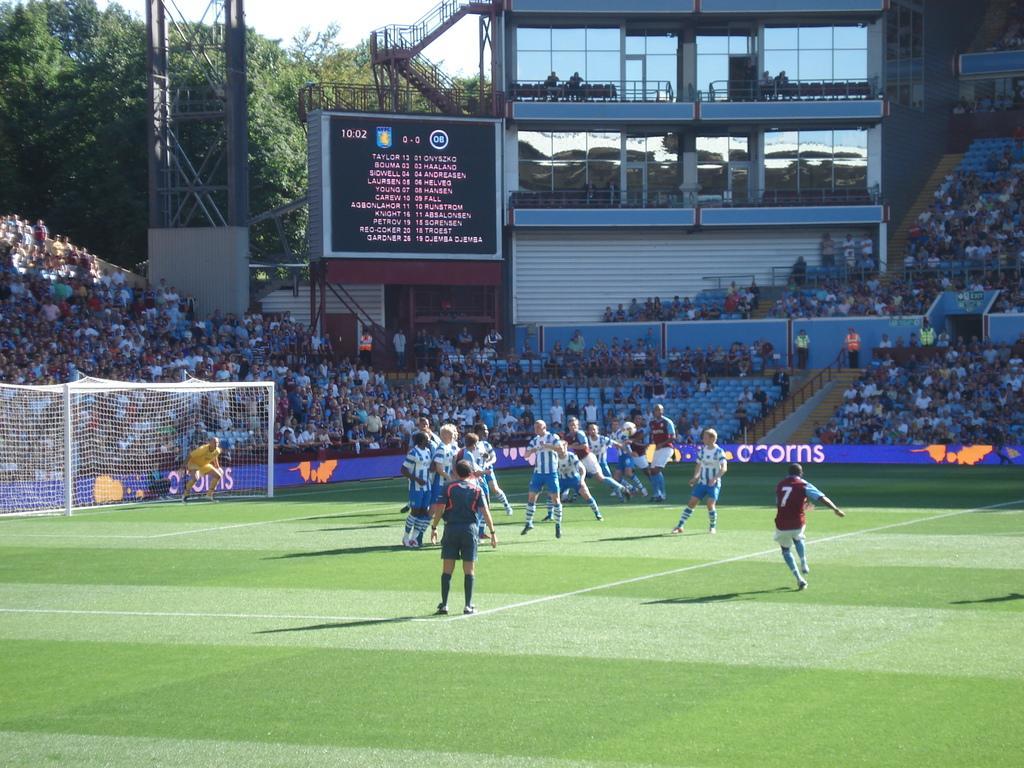Describe this image in one or two sentences. In the picture we can see group of people wearing sports dress playing football and in the background of the picture there are some persons sitting on chairs, there is a score board, there are some trees and top of the picture there is clear sky. 